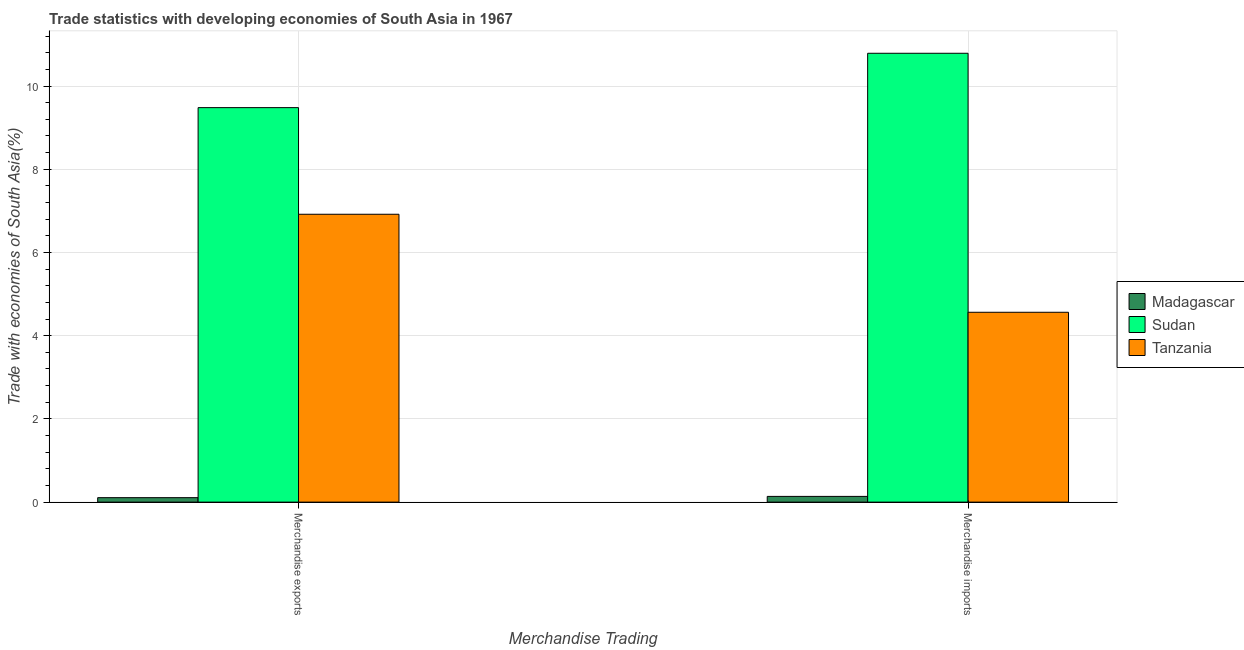How many groups of bars are there?
Make the answer very short. 2. What is the label of the 1st group of bars from the left?
Provide a short and direct response. Merchandise exports. What is the merchandise exports in Tanzania?
Your answer should be very brief. 6.92. Across all countries, what is the maximum merchandise exports?
Provide a short and direct response. 9.48. Across all countries, what is the minimum merchandise exports?
Your answer should be very brief. 0.11. In which country was the merchandise exports maximum?
Offer a terse response. Sudan. In which country was the merchandise imports minimum?
Your answer should be compact. Madagascar. What is the total merchandise imports in the graph?
Your answer should be compact. 15.49. What is the difference between the merchandise imports in Sudan and that in Madagascar?
Provide a succinct answer. 10.65. What is the difference between the merchandise exports in Sudan and the merchandise imports in Madagascar?
Your response must be concise. 9.34. What is the average merchandise imports per country?
Make the answer very short. 5.16. What is the difference between the merchandise imports and merchandise exports in Madagascar?
Offer a terse response. 0.03. What is the ratio of the merchandise imports in Madagascar to that in Tanzania?
Your answer should be very brief. 0.03. Is the merchandise exports in Sudan less than that in Tanzania?
Offer a terse response. No. What does the 3rd bar from the left in Merchandise imports represents?
Provide a succinct answer. Tanzania. What does the 3rd bar from the right in Merchandise exports represents?
Offer a terse response. Madagascar. How many bars are there?
Offer a very short reply. 6. How many countries are there in the graph?
Your response must be concise. 3. What is the difference between two consecutive major ticks on the Y-axis?
Provide a short and direct response. 2. Does the graph contain any zero values?
Provide a succinct answer. No. Where does the legend appear in the graph?
Give a very brief answer. Center right. How are the legend labels stacked?
Provide a succinct answer. Vertical. What is the title of the graph?
Make the answer very short. Trade statistics with developing economies of South Asia in 1967. What is the label or title of the X-axis?
Provide a succinct answer. Merchandise Trading. What is the label or title of the Y-axis?
Provide a short and direct response. Trade with economies of South Asia(%). What is the Trade with economies of South Asia(%) in Madagascar in Merchandise exports?
Make the answer very short. 0.11. What is the Trade with economies of South Asia(%) of Sudan in Merchandise exports?
Make the answer very short. 9.48. What is the Trade with economies of South Asia(%) of Tanzania in Merchandise exports?
Keep it short and to the point. 6.92. What is the Trade with economies of South Asia(%) in Madagascar in Merchandise imports?
Your answer should be compact. 0.14. What is the Trade with economies of South Asia(%) of Sudan in Merchandise imports?
Provide a short and direct response. 10.79. What is the Trade with economies of South Asia(%) in Tanzania in Merchandise imports?
Provide a succinct answer. 4.56. Across all Merchandise Trading, what is the maximum Trade with economies of South Asia(%) in Madagascar?
Offer a terse response. 0.14. Across all Merchandise Trading, what is the maximum Trade with economies of South Asia(%) of Sudan?
Provide a short and direct response. 10.79. Across all Merchandise Trading, what is the maximum Trade with economies of South Asia(%) in Tanzania?
Offer a very short reply. 6.92. Across all Merchandise Trading, what is the minimum Trade with economies of South Asia(%) in Madagascar?
Offer a very short reply. 0.11. Across all Merchandise Trading, what is the minimum Trade with economies of South Asia(%) in Sudan?
Your answer should be very brief. 9.48. Across all Merchandise Trading, what is the minimum Trade with economies of South Asia(%) in Tanzania?
Offer a terse response. 4.56. What is the total Trade with economies of South Asia(%) of Madagascar in the graph?
Offer a terse response. 0.24. What is the total Trade with economies of South Asia(%) of Sudan in the graph?
Keep it short and to the point. 20.27. What is the total Trade with economies of South Asia(%) of Tanzania in the graph?
Make the answer very short. 11.48. What is the difference between the Trade with economies of South Asia(%) of Madagascar in Merchandise exports and that in Merchandise imports?
Offer a very short reply. -0.03. What is the difference between the Trade with economies of South Asia(%) of Sudan in Merchandise exports and that in Merchandise imports?
Your answer should be compact. -1.31. What is the difference between the Trade with economies of South Asia(%) of Tanzania in Merchandise exports and that in Merchandise imports?
Offer a terse response. 2.36. What is the difference between the Trade with economies of South Asia(%) of Madagascar in Merchandise exports and the Trade with economies of South Asia(%) of Sudan in Merchandise imports?
Your answer should be compact. -10.68. What is the difference between the Trade with economies of South Asia(%) of Madagascar in Merchandise exports and the Trade with economies of South Asia(%) of Tanzania in Merchandise imports?
Your answer should be very brief. -4.46. What is the difference between the Trade with economies of South Asia(%) of Sudan in Merchandise exports and the Trade with economies of South Asia(%) of Tanzania in Merchandise imports?
Make the answer very short. 4.92. What is the average Trade with economies of South Asia(%) in Madagascar per Merchandise Trading?
Make the answer very short. 0.12. What is the average Trade with economies of South Asia(%) in Sudan per Merchandise Trading?
Provide a succinct answer. 10.13. What is the average Trade with economies of South Asia(%) of Tanzania per Merchandise Trading?
Your answer should be very brief. 5.74. What is the difference between the Trade with economies of South Asia(%) in Madagascar and Trade with economies of South Asia(%) in Sudan in Merchandise exports?
Your answer should be very brief. -9.37. What is the difference between the Trade with economies of South Asia(%) in Madagascar and Trade with economies of South Asia(%) in Tanzania in Merchandise exports?
Give a very brief answer. -6.81. What is the difference between the Trade with economies of South Asia(%) of Sudan and Trade with economies of South Asia(%) of Tanzania in Merchandise exports?
Offer a terse response. 2.56. What is the difference between the Trade with economies of South Asia(%) of Madagascar and Trade with economies of South Asia(%) of Sudan in Merchandise imports?
Give a very brief answer. -10.65. What is the difference between the Trade with economies of South Asia(%) of Madagascar and Trade with economies of South Asia(%) of Tanzania in Merchandise imports?
Your response must be concise. -4.43. What is the difference between the Trade with economies of South Asia(%) in Sudan and Trade with economies of South Asia(%) in Tanzania in Merchandise imports?
Offer a very short reply. 6.23. What is the ratio of the Trade with economies of South Asia(%) of Madagascar in Merchandise exports to that in Merchandise imports?
Offer a very short reply. 0.78. What is the ratio of the Trade with economies of South Asia(%) of Sudan in Merchandise exports to that in Merchandise imports?
Provide a succinct answer. 0.88. What is the ratio of the Trade with economies of South Asia(%) of Tanzania in Merchandise exports to that in Merchandise imports?
Offer a very short reply. 1.52. What is the difference between the highest and the second highest Trade with economies of South Asia(%) in Madagascar?
Ensure brevity in your answer.  0.03. What is the difference between the highest and the second highest Trade with economies of South Asia(%) of Sudan?
Ensure brevity in your answer.  1.31. What is the difference between the highest and the second highest Trade with economies of South Asia(%) of Tanzania?
Provide a succinct answer. 2.36. What is the difference between the highest and the lowest Trade with economies of South Asia(%) in Madagascar?
Make the answer very short. 0.03. What is the difference between the highest and the lowest Trade with economies of South Asia(%) of Sudan?
Offer a very short reply. 1.31. What is the difference between the highest and the lowest Trade with economies of South Asia(%) of Tanzania?
Provide a succinct answer. 2.36. 